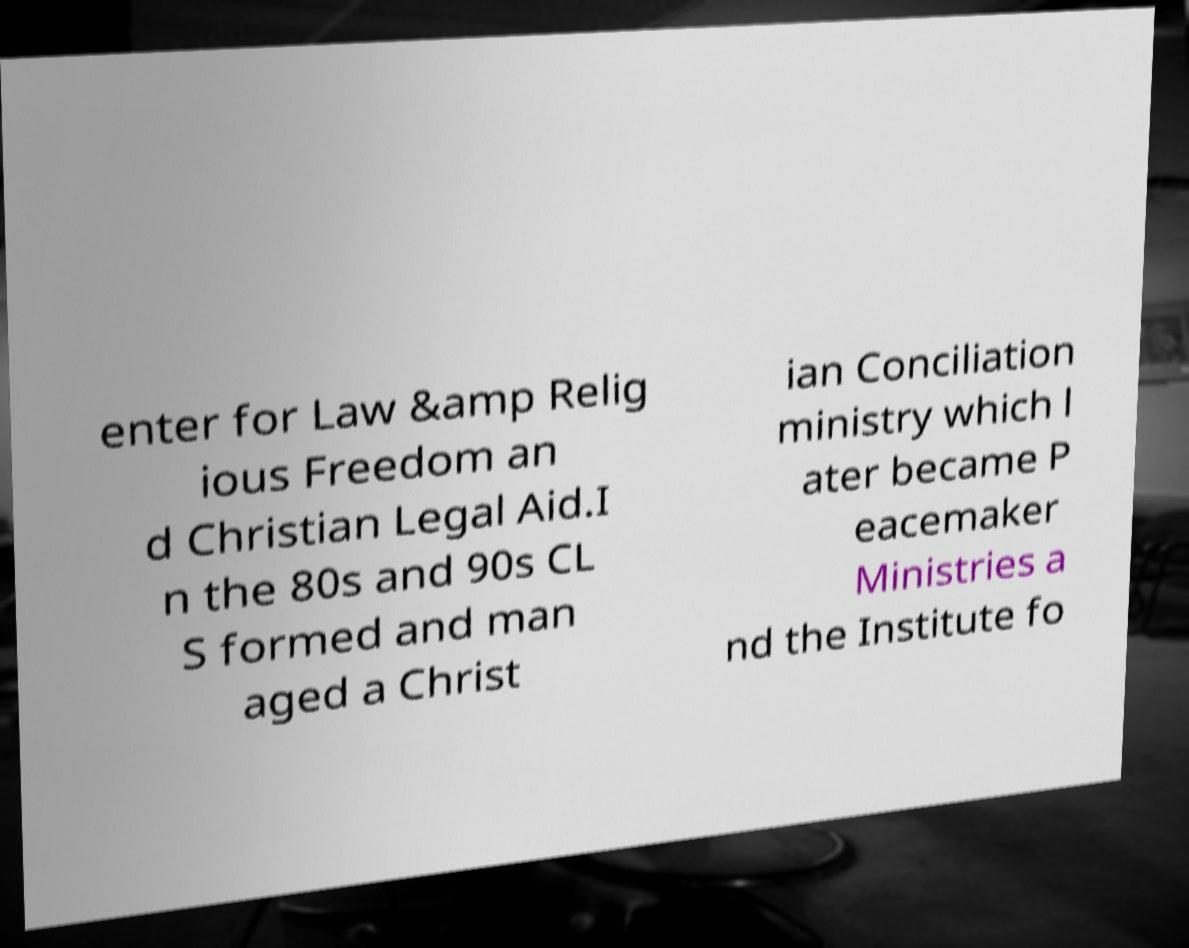Could you assist in decoding the text presented in this image and type it out clearly? enter for Law &amp Relig ious Freedom an d Christian Legal Aid.I n the 80s and 90s CL S formed and man aged a Christ ian Conciliation ministry which l ater became P eacemaker Ministries a nd the Institute fo 